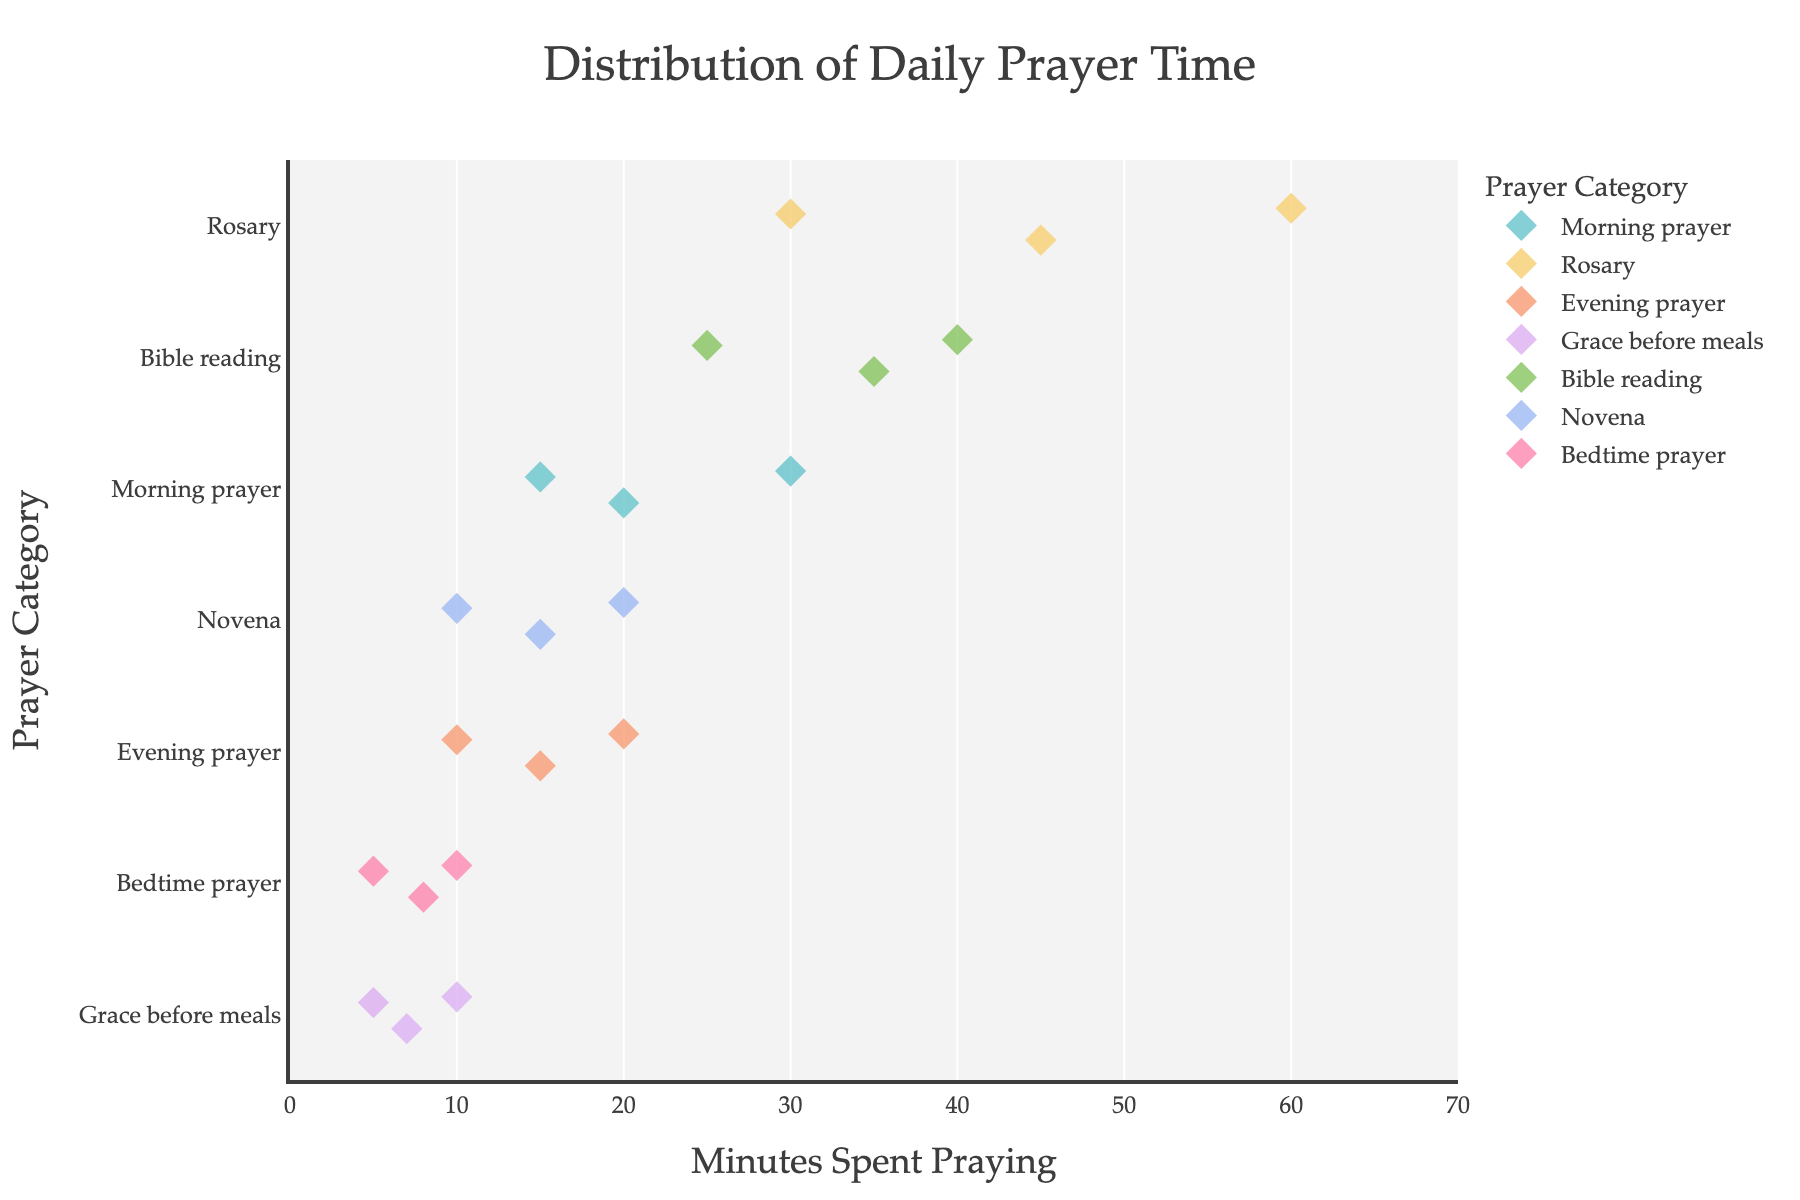How many categories of prayer are shown in the plot? There are six different categories listed along the y-axis of the plot: Morning prayer, Rosary, Evening prayer, Grace before meals, Bible reading, and Novena.
Answer: Six What is the total number of data points for Evening prayer? Count the number of points corresponding to the 'Evening prayer' category: 10, 20, and 15 minutes, which makes a total of three points.
Answer: Three Which prayer category has the most varied range of time spent? Look at the spread of data points horizontally for each category. The Rosary category has points ranging from 30 to 60 minutes, indicating a broad range.
Answer: Rosary What is the average time spent on Morning prayer? Sum the time spent on Morning prayer (15, 30, 20) and then divide by the number of data points. (15 + 30 + 20) / 3 = 65 / 3 = approximately 21.67 minutes.
Answer: 21.67 minutes Which prayer category has the highest median time spent? To find the median, list each category's times in order and find the middle value. The categories are: Morning prayer (15, 20, 30 median = 20), Rosary (30, 45, 60 median = 45), Evening prayer (10, 15, 20 median = 15), Grace before meals (5, 7, 10 median = 7), Bible reading (25, 35, 40 median = 35), Novena (10, 15, 20 median = 15), Bedtime prayer (5, 8, 10 median = 8). The Rosary category has the highest median time of 45 minutes.
Answer: Rosary Which category has the fewest data points and how many does it have? Count the data points for each category. The category 'Bedtime prayer' has 3 data points (5, 8, and 10 minutes), which is the fewest.
Answer: Bedtime prayer, three How many prayer categories have a median time of 15 minutes or less? Calculate the median for each category and count which are 15 minutes or less. Morning prayer (20), Rosary (45), Evening prayer (15), Grace before meals (7), Bible reading (35), Novena (15), Bedtime prayer (8). The prayer categories that meet the criteria are Evening prayer, Grace before meals, Novena, and Bedtime prayer, making a total of four categories.
Answer: Four 